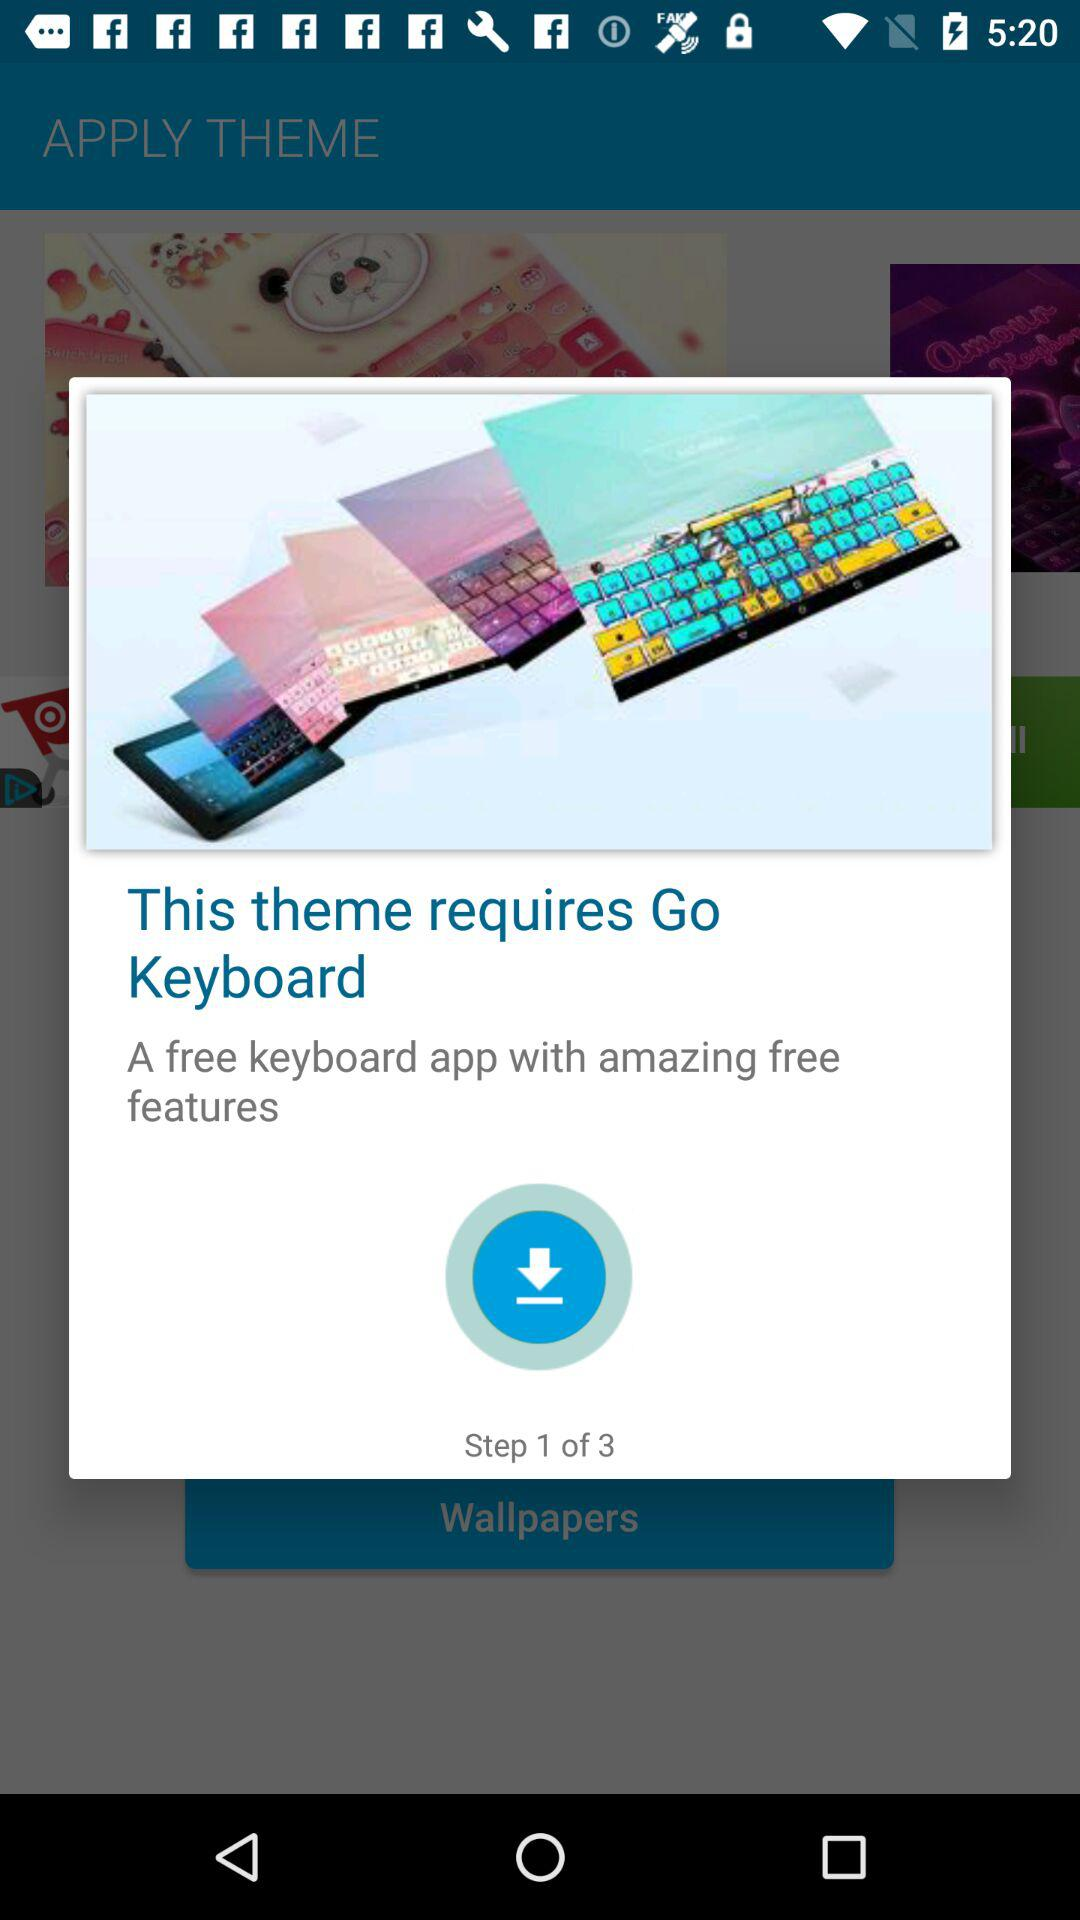How many steps does the user have to go through to download the theme?
Answer the question using a single word or phrase. 3 